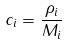<formula> <loc_0><loc_0><loc_500><loc_500>c _ { i } = \frac { \rho _ { i } } { M _ { i } }</formula> 